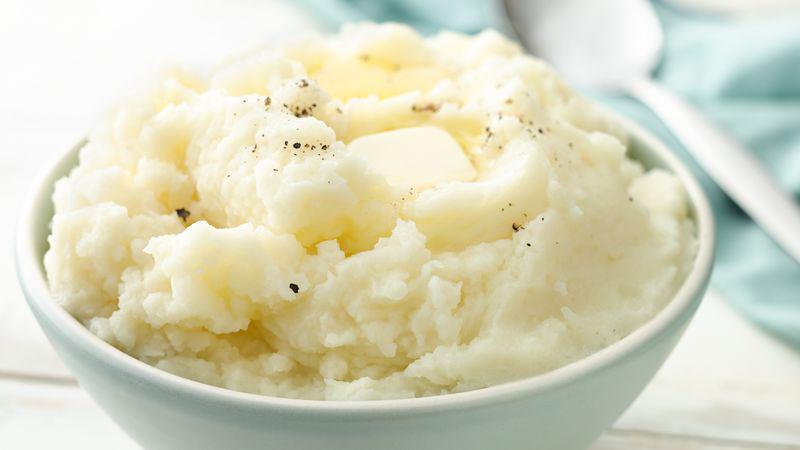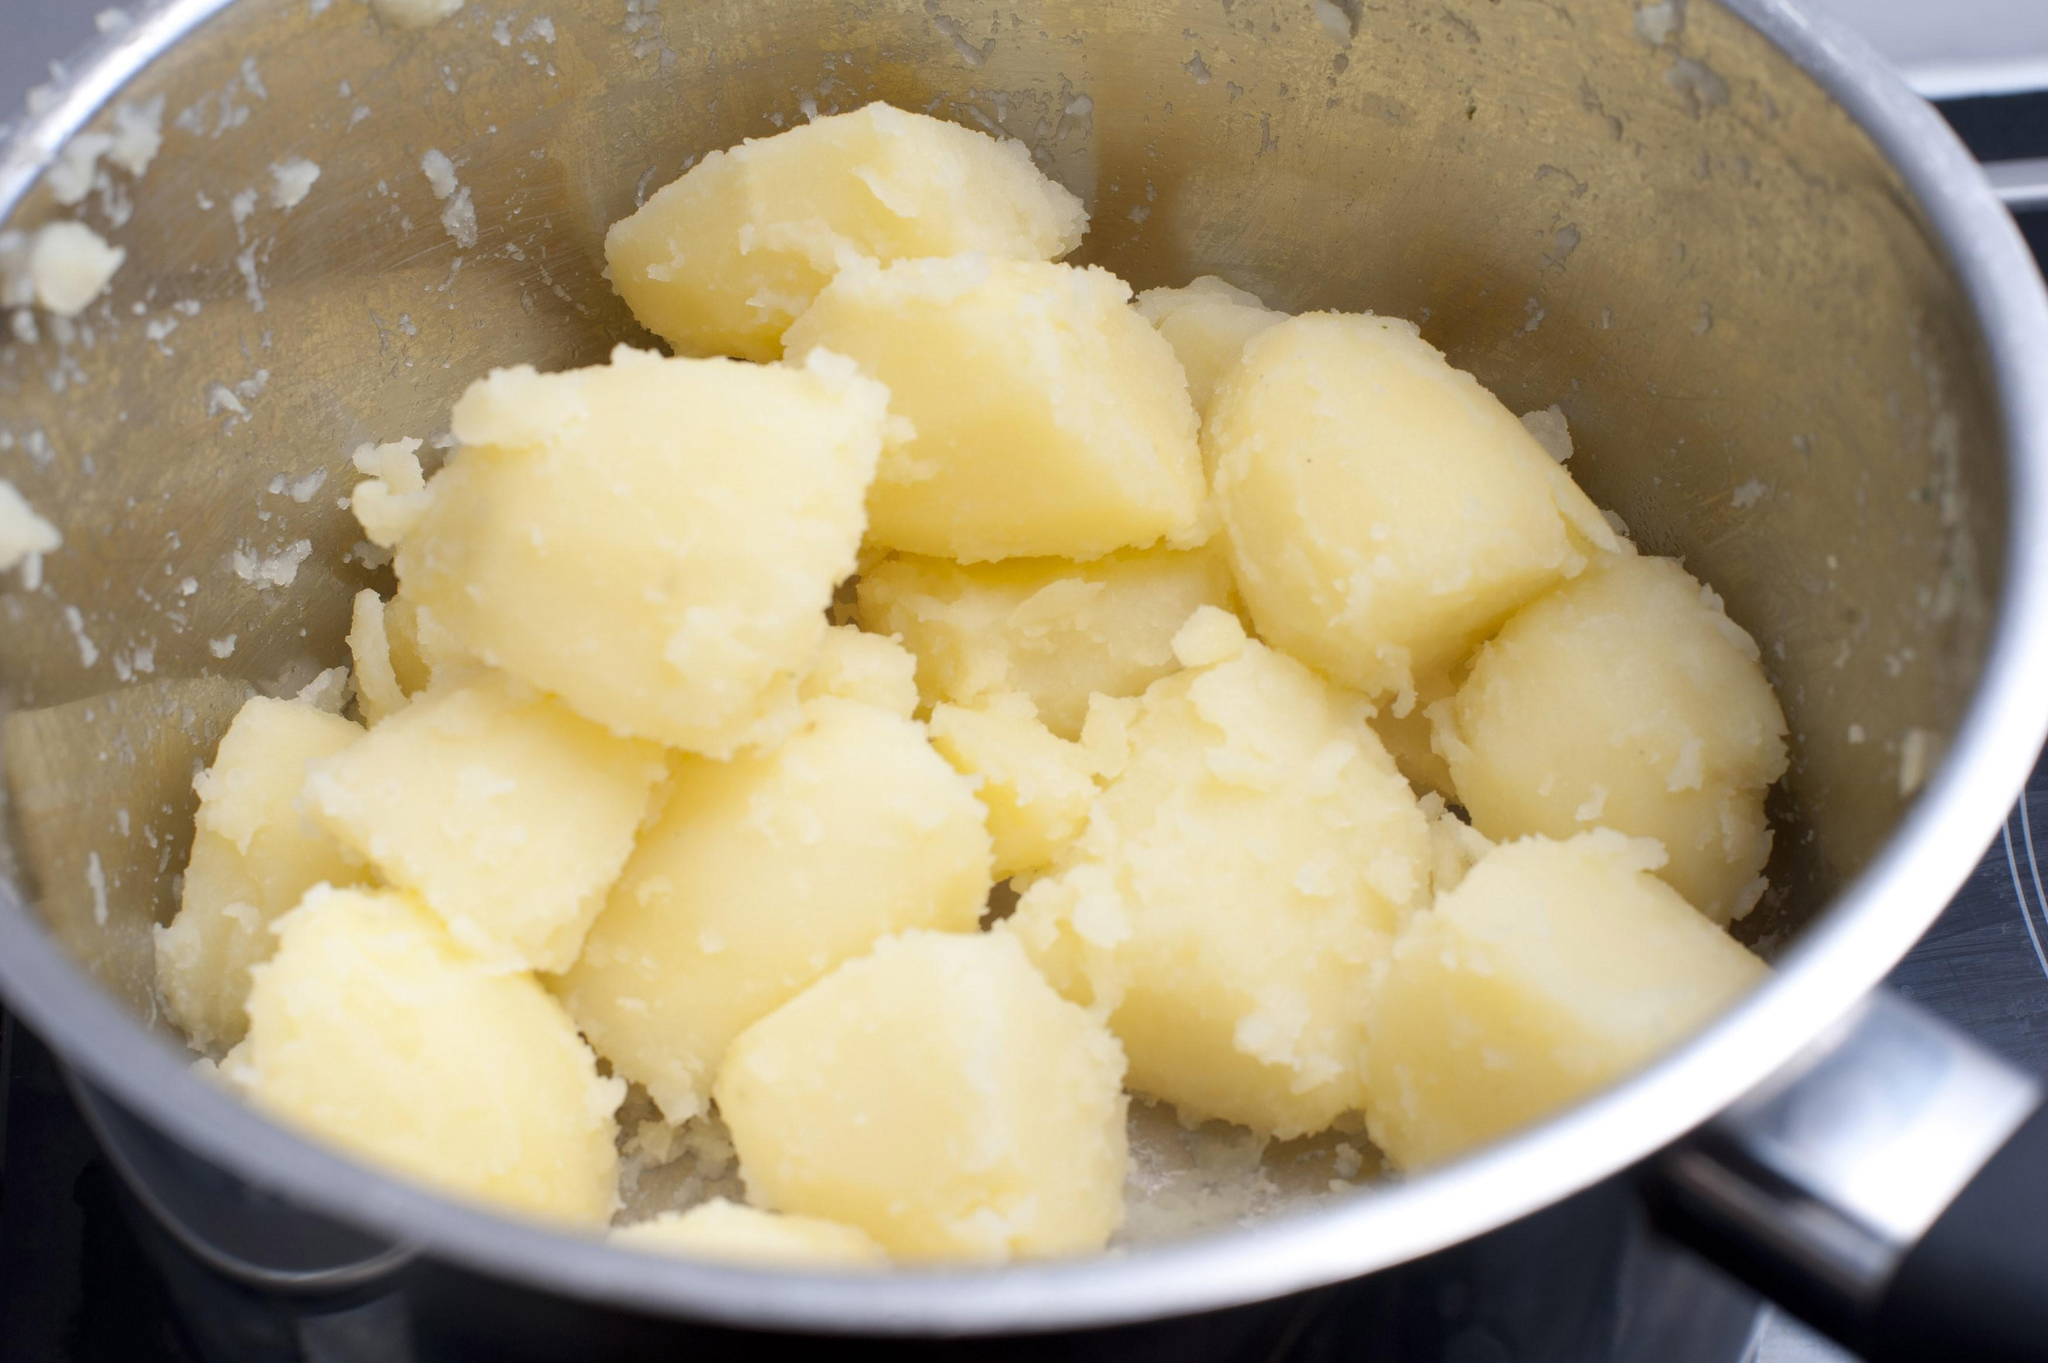The first image is the image on the left, the second image is the image on the right. For the images shown, is this caption "At least one bowl is white." true? Answer yes or no. Yes. The first image is the image on the left, the second image is the image on the right. Analyze the images presented: Is the assertion "At least one image shows mashed potatoes served in a white bowl." valid? Answer yes or no. Yes. 